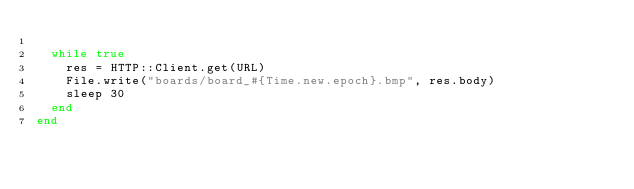<code> <loc_0><loc_0><loc_500><loc_500><_Crystal_>
  while true
    res = HTTP::Client.get(URL)
    File.write("boards/board_#{Time.new.epoch}.bmp", res.body)
    sleep 30
  end
end
</code> 